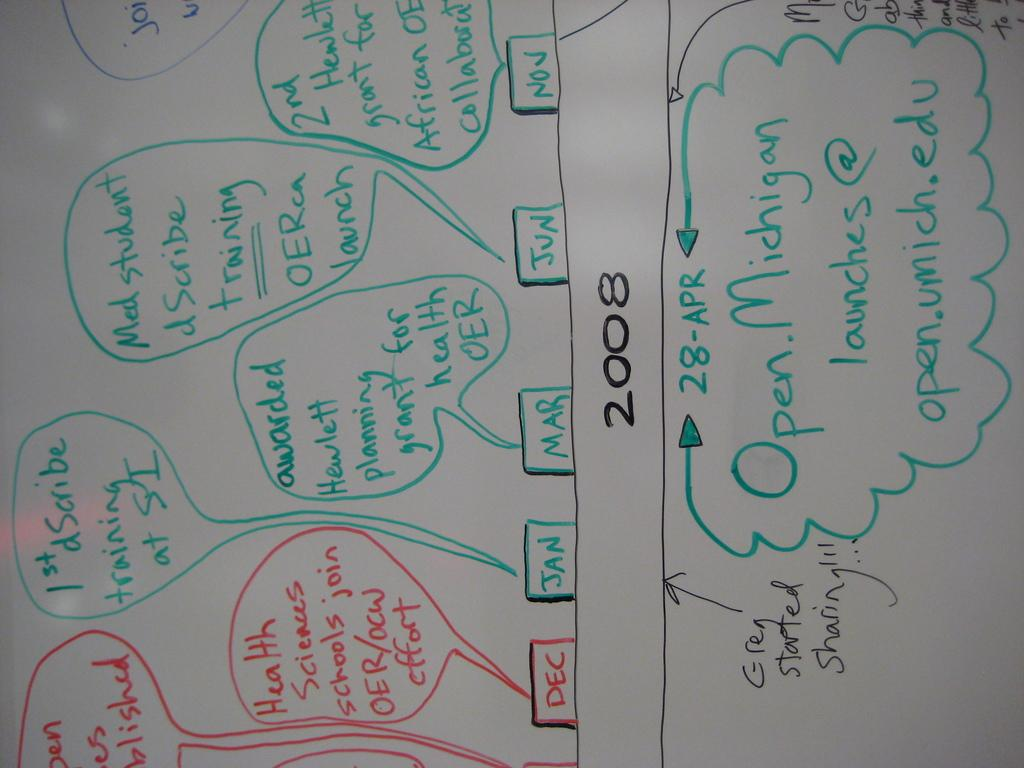Provide a one-sentence caption for the provided image. A timeline for the year 2008 for university health sciences staff at the University of Michigan. 